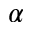<formula> <loc_0><loc_0><loc_500><loc_500>\alpha</formula> 